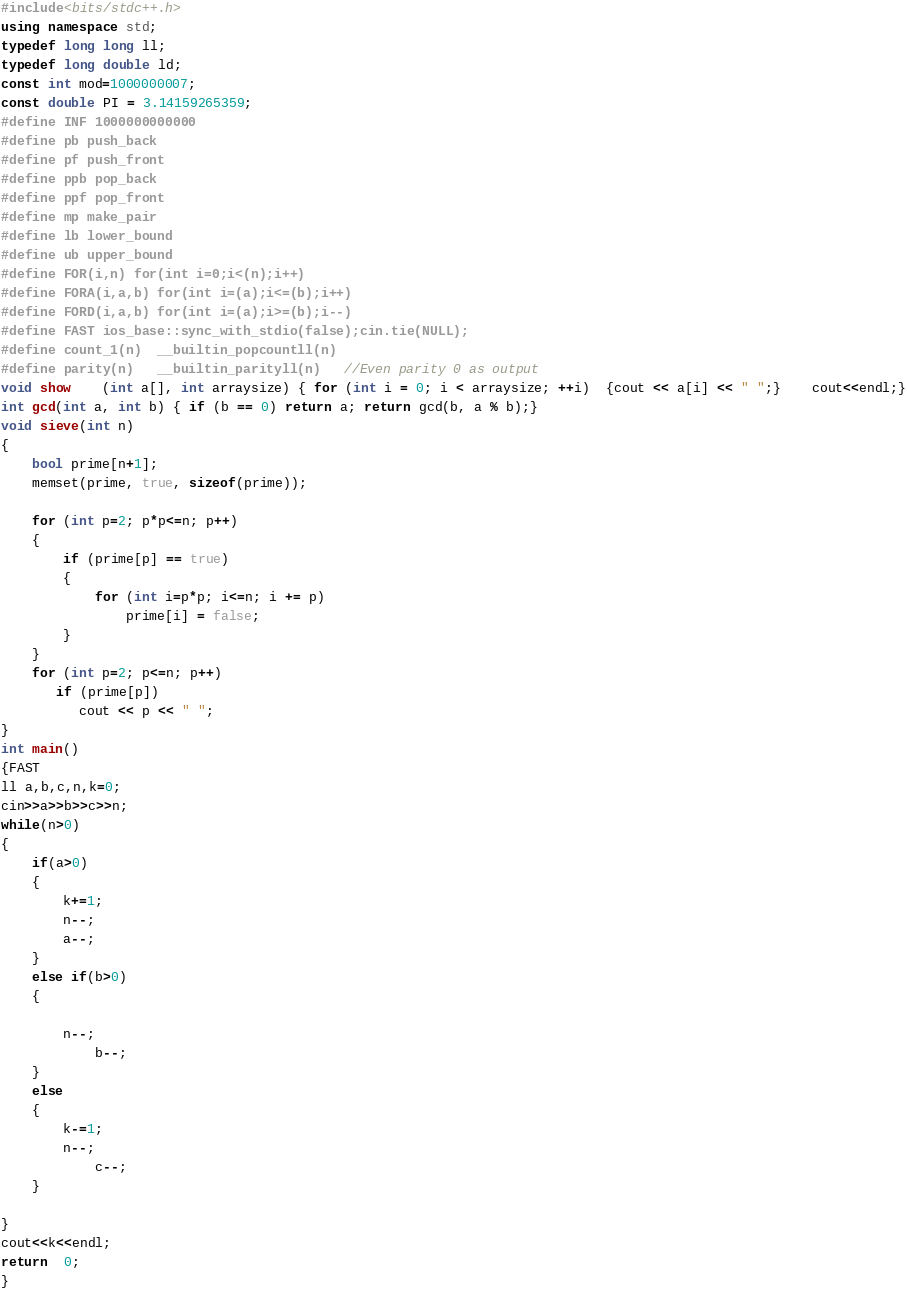<code> <loc_0><loc_0><loc_500><loc_500><_C++_>#include<bits/stdc++.h>
using namespace std;
typedef long long ll;
typedef long double ld;
const int mod=1000000007;
const double PI = 3.14159265359;
#define INF 1000000000000
#define pb push_back
#define pf push_front
#define ppb pop_back
#define ppf pop_front
#define mp make_pair
#define lb lower_bound
#define ub upper_bound
#define FOR(i,n) for(int i=0;i<(n);i++)
#define FORA(i,a,b) for(int i=(a);i<=(b);i++)
#define FORD(i,a,b) for(int i=(a);i>=(b);i--)
#define FAST ios_base::sync_with_stdio(false);cin.tie(NULL);
#define count_1(n)  __builtin_popcountll(n)
#define parity(n)   __builtin_parityll(n)   //Even parity 0 as output
void show    (int a[], int arraysize) { for (int i = 0; i < arraysize; ++i)  {cout << a[i] << " ";}	cout<<endl;}
int gcd(int a, int b) { if (b == 0) return a; return gcd(b, a % b);}
void sieve(int n)
{
    bool prime[n+1];
    memset(prime, true, sizeof(prime));

    for (int p=2; p*p<=n; p++)
    {
        if (prime[p] == true)
        {
            for (int i=p*p; i<=n; i += p)
                prime[i] = false;
        }
    }
    for (int p=2; p<=n; p++)
       if (prime[p])
          cout << p << " ";
}
int main()
{FAST
ll a,b,c,n,k=0;
cin>>a>>b>>c>>n;
while(n>0)
{
	if(a>0)
	{
		k+=1;
		n--;
		a--;
	}
	else if(b>0)
	{
		
		n--;
			b--;
	}
    else
	{
		k-=1;
		n--;
			c--;
	}
	
}
cout<<k<<endl;
return  0;
}



</code> 